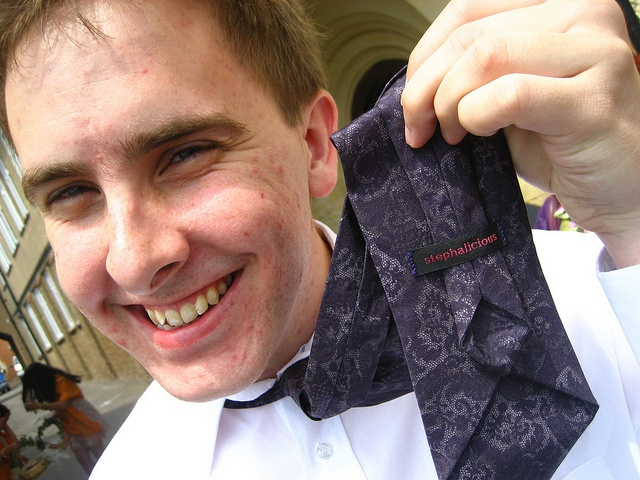Describe the objects in this image and their specific colors. I can see people in white, maroon, black, brown, and tan tones, tie in maroon, black, gray, and purple tones, people in maroon, black, and gray tones, and people in maroon, black, and gray tones in this image. 